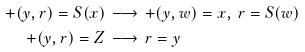<formula> <loc_0><loc_0><loc_500><loc_500>+ ( y , r ) = S ( x ) & \, \longrightarrow \, + ( y , w ) = x , \, r = S ( w ) \\ + ( y , r ) = Z & \, \longrightarrow \, r = y</formula> 